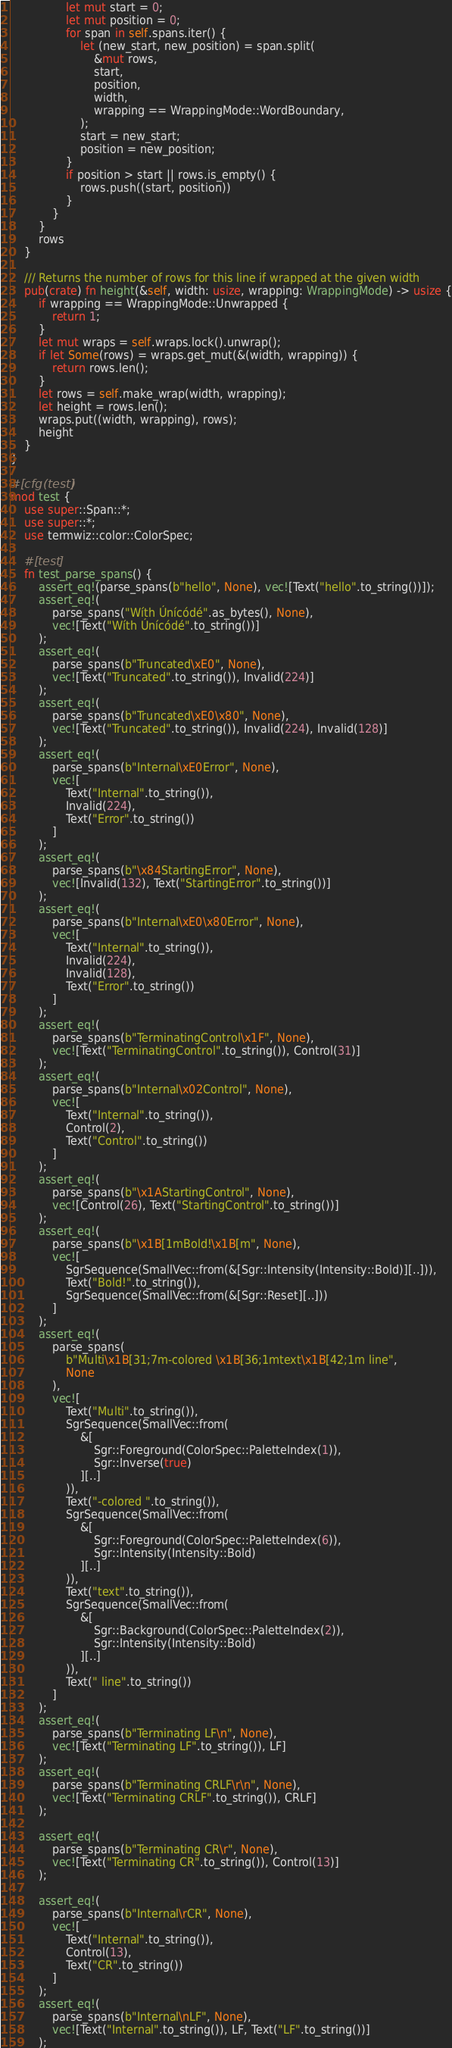Convert code to text. <code><loc_0><loc_0><loc_500><loc_500><_Rust_>                let mut start = 0;
                let mut position = 0;
                for span in self.spans.iter() {
                    let (new_start, new_position) = span.split(
                        &mut rows,
                        start,
                        position,
                        width,
                        wrapping == WrappingMode::WordBoundary,
                    );
                    start = new_start;
                    position = new_position;
                }
                if position > start || rows.is_empty() {
                    rows.push((start, position))
                }
            }
        }
        rows
    }

    /// Returns the number of rows for this line if wrapped at the given width
    pub(crate) fn height(&self, width: usize, wrapping: WrappingMode) -> usize {
        if wrapping == WrappingMode::Unwrapped {
            return 1;
        }
        let mut wraps = self.wraps.lock().unwrap();
        if let Some(rows) = wraps.get_mut(&(width, wrapping)) {
            return rows.len();
        }
        let rows = self.make_wrap(width, wrapping);
        let height = rows.len();
        wraps.put((width, wrapping), rows);
        height
    }
}

#[cfg(test)]
mod test {
    use super::Span::*;
    use super::*;
    use termwiz::color::ColorSpec;

    #[test]
    fn test_parse_spans() {
        assert_eq!(parse_spans(b"hello", None), vec![Text("hello".to_string())]);
        assert_eq!(
            parse_spans("Wíth Únícódé".as_bytes(), None),
            vec![Text("Wíth Únícódé".to_string())]
        );
        assert_eq!(
            parse_spans(b"Truncated\xE0", None),
            vec![Text("Truncated".to_string()), Invalid(224)]
        );
        assert_eq!(
            parse_spans(b"Truncated\xE0\x80", None),
            vec![Text("Truncated".to_string()), Invalid(224), Invalid(128)]
        );
        assert_eq!(
            parse_spans(b"Internal\xE0Error", None),
            vec![
                Text("Internal".to_string()),
                Invalid(224),
                Text("Error".to_string())
            ]
        );
        assert_eq!(
            parse_spans(b"\x84StartingError", None),
            vec![Invalid(132), Text("StartingError".to_string())]
        );
        assert_eq!(
            parse_spans(b"Internal\xE0\x80Error", None),
            vec![
                Text("Internal".to_string()),
                Invalid(224),
                Invalid(128),
                Text("Error".to_string())
            ]
        );
        assert_eq!(
            parse_spans(b"TerminatingControl\x1F", None),
            vec![Text("TerminatingControl".to_string()), Control(31)]
        );
        assert_eq!(
            parse_spans(b"Internal\x02Control", None),
            vec![
                Text("Internal".to_string()),
                Control(2),
                Text("Control".to_string())
            ]
        );
        assert_eq!(
            parse_spans(b"\x1AStartingControl", None),
            vec![Control(26), Text("StartingControl".to_string())]
        );
        assert_eq!(
            parse_spans(b"\x1B[1mBold!\x1B[m", None),
            vec![
                SgrSequence(SmallVec::from(&[Sgr::Intensity(Intensity::Bold)][..])),
                Text("Bold!".to_string()),
                SgrSequence(SmallVec::from(&[Sgr::Reset][..]))
            ]
        );
        assert_eq!(
            parse_spans(
                b"Multi\x1B[31;7m-colored \x1B[36;1mtext\x1B[42;1m line",
                None
            ),
            vec![
                Text("Multi".to_string()),
                SgrSequence(SmallVec::from(
                    &[
                        Sgr::Foreground(ColorSpec::PaletteIndex(1)),
                        Sgr::Inverse(true)
                    ][..]
                )),
                Text("-colored ".to_string()),
                SgrSequence(SmallVec::from(
                    &[
                        Sgr::Foreground(ColorSpec::PaletteIndex(6)),
                        Sgr::Intensity(Intensity::Bold)
                    ][..]
                )),
                Text("text".to_string()),
                SgrSequence(SmallVec::from(
                    &[
                        Sgr::Background(ColorSpec::PaletteIndex(2)),
                        Sgr::Intensity(Intensity::Bold)
                    ][..]
                )),
                Text(" line".to_string())
            ]
        );
        assert_eq!(
            parse_spans(b"Terminating LF\n", None),
            vec![Text("Terminating LF".to_string()), LF]
        );
        assert_eq!(
            parse_spans(b"Terminating CRLF\r\n", None),
            vec![Text("Terminating CRLF".to_string()), CRLF]
        );

        assert_eq!(
            parse_spans(b"Terminating CR\r", None),
            vec![Text("Terminating CR".to_string()), Control(13)]
        );

        assert_eq!(
            parse_spans(b"Internal\rCR", None),
            vec![
                Text("Internal".to_string()),
                Control(13),
                Text("CR".to_string())
            ]
        );
        assert_eq!(
            parse_spans(b"Internal\nLF", None),
            vec![Text("Internal".to_string()), LF, Text("LF".to_string())]
        );</code> 